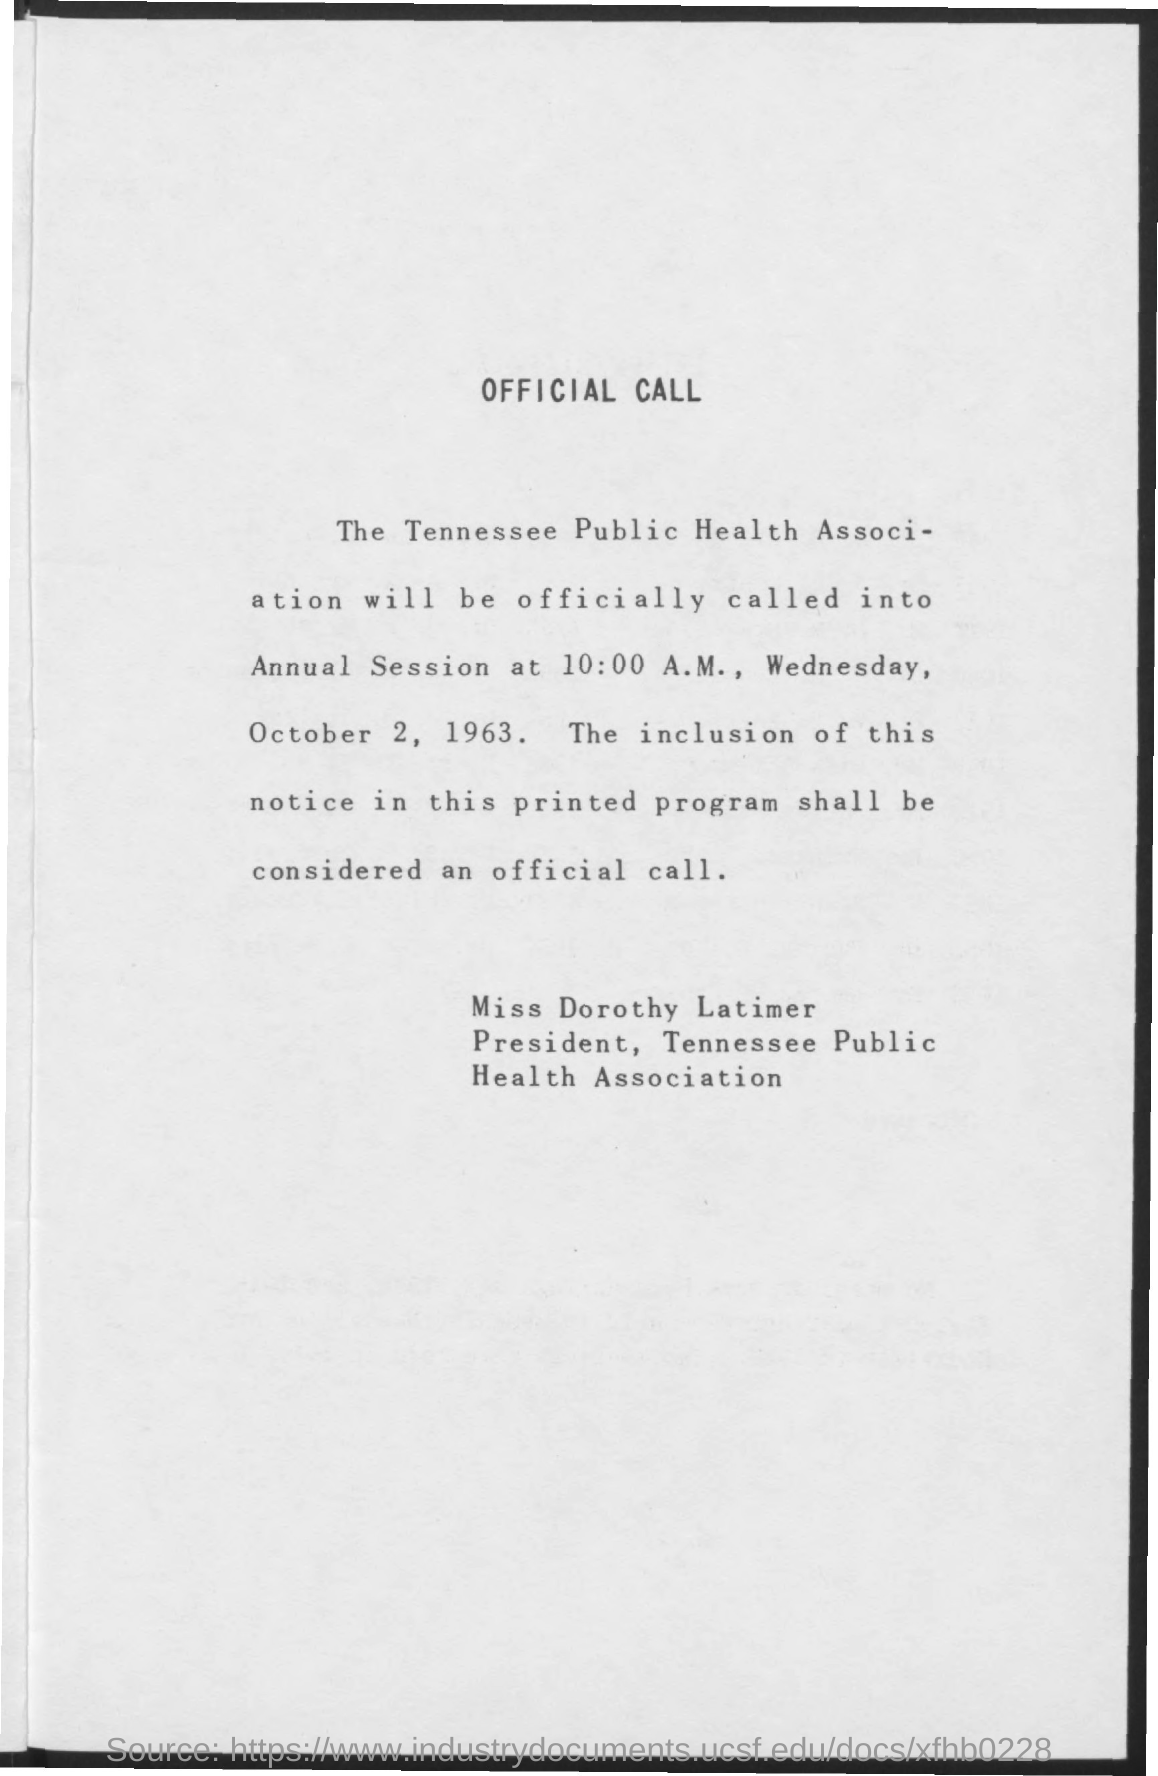On which date will the Tennessee public health association be officially called into annual session?
Keep it short and to the point. Wednesday, October 2, 1963. What time will the Tennessee public health association be officially called into annual session?
Offer a very short reply. At 10:00 a.m. 